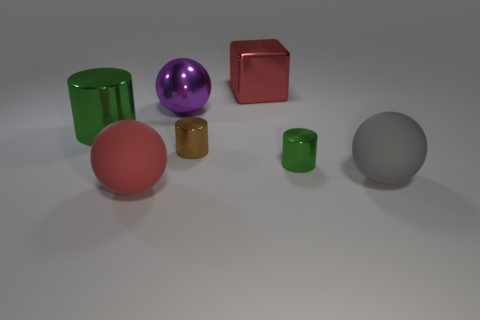What number of objects are big things that are to the right of the small green cylinder or large green rubber objects? Assessing the scene, it appears there is one large red cube to the right of the small green cylinder. As for large green rubber objects, I cannot determine material properties from the image, but if we consider the large green object as rubber, there would still be just one object that meets the criteria. 